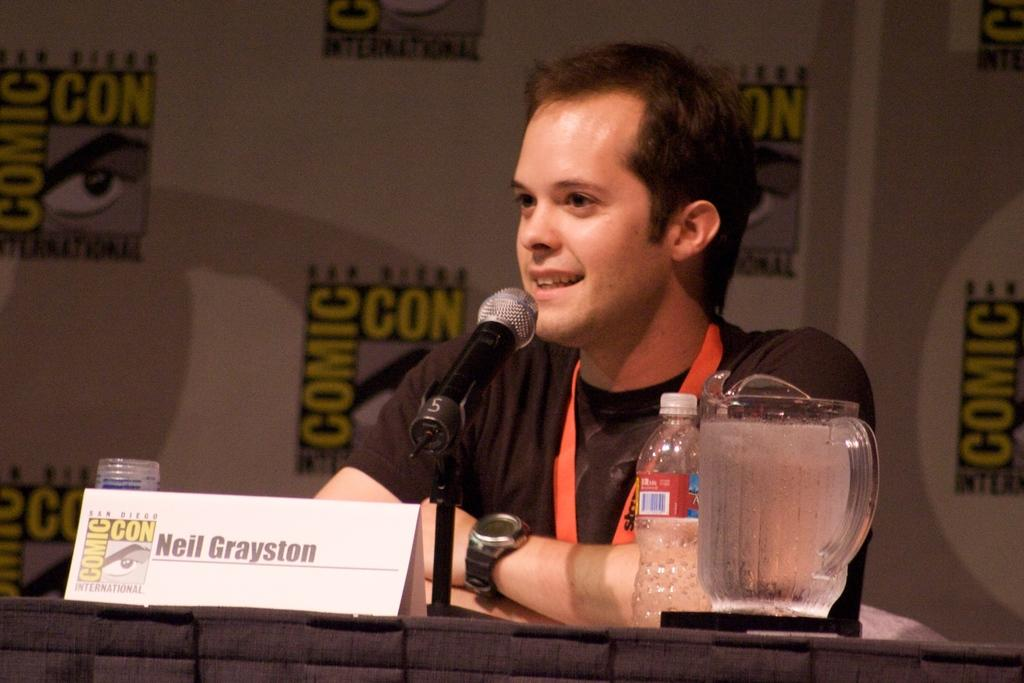What is the position of the man in the image? The man is seated in the image. What object is in front of the man? There is a microphone, a bottle, a jug, and a name board in front of the man. What might the man be using the microphone for? The man might be using the microphone for speaking or singing. What other items are on the table in the image? There are other things on the table, but their exact nature is not mentioned in the facts. What type of zinc is present on the table in the image? There is no mention of zinc in the image, so it cannot be determined if any zinc is present. How many cards are visible on the table in the image? There is no mention of cards in the image, so it cannot be determined if any cards are present. 